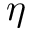Convert formula to latex. <formula><loc_0><loc_0><loc_500><loc_500>\eta</formula> 